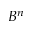<formula> <loc_0><loc_0><loc_500><loc_500>B ^ { n }</formula> 